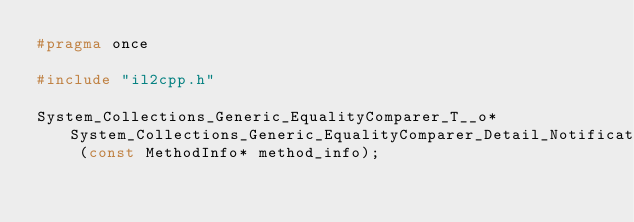Convert code to text. <code><loc_0><loc_0><loc_500><loc_500><_C_>#pragma once

#include "il2cpp.h"

System_Collections_Generic_EqualityComparer_T__o* System_Collections_Generic_EqualityComparer_Detail_NotificationEventInt___get_Default (const MethodInfo* method_info);</code> 